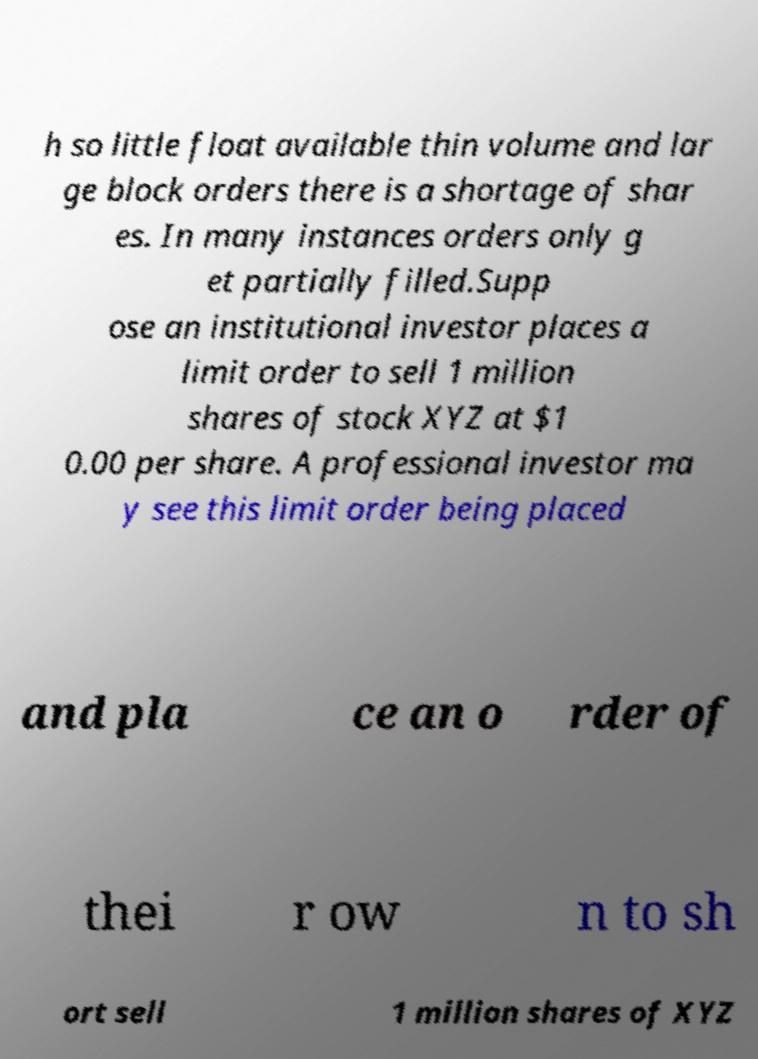For documentation purposes, I need the text within this image transcribed. Could you provide that? h so little float available thin volume and lar ge block orders there is a shortage of shar es. In many instances orders only g et partially filled.Supp ose an institutional investor places a limit order to sell 1 million shares of stock XYZ at $1 0.00 per share. A professional investor ma y see this limit order being placed and pla ce an o rder of thei r ow n to sh ort sell 1 million shares of XYZ 